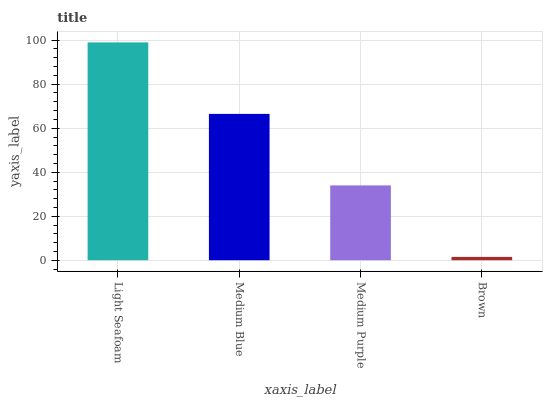Is Medium Blue the minimum?
Answer yes or no. No. Is Medium Blue the maximum?
Answer yes or no. No. Is Light Seafoam greater than Medium Blue?
Answer yes or no. Yes. Is Medium Blue less than Light Seafoam?
Answer yes or no. Yes. Is Medium Blue greater than Light Seafoam?
Answer yes or no. No. Is Light Seafoam less than Medium Blue?
Answer yes or no. No. Is Medium Blue the high median?
Answer yes or no. Yes. Is Medium Purple the low median?
Answer yes or no. Yes. Is Light Seafoam the high median?
Answer yes or no. No. Is Medium Blue the low median?
Answer yes or no. No. 